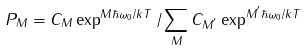<formula> <loc_0><loc_0><loc_500><loc_500>P _ { M } = C _ { M } \exp ^ { M \hbar { \omega } _ { 0 } / k T } / \sum _ { M } C _ { M ^ { ^ { \prime } } } \exp ^ { M ^ { ^ { \prime } } \hbar { \omega } _ { 0 } / k T }</formula> 